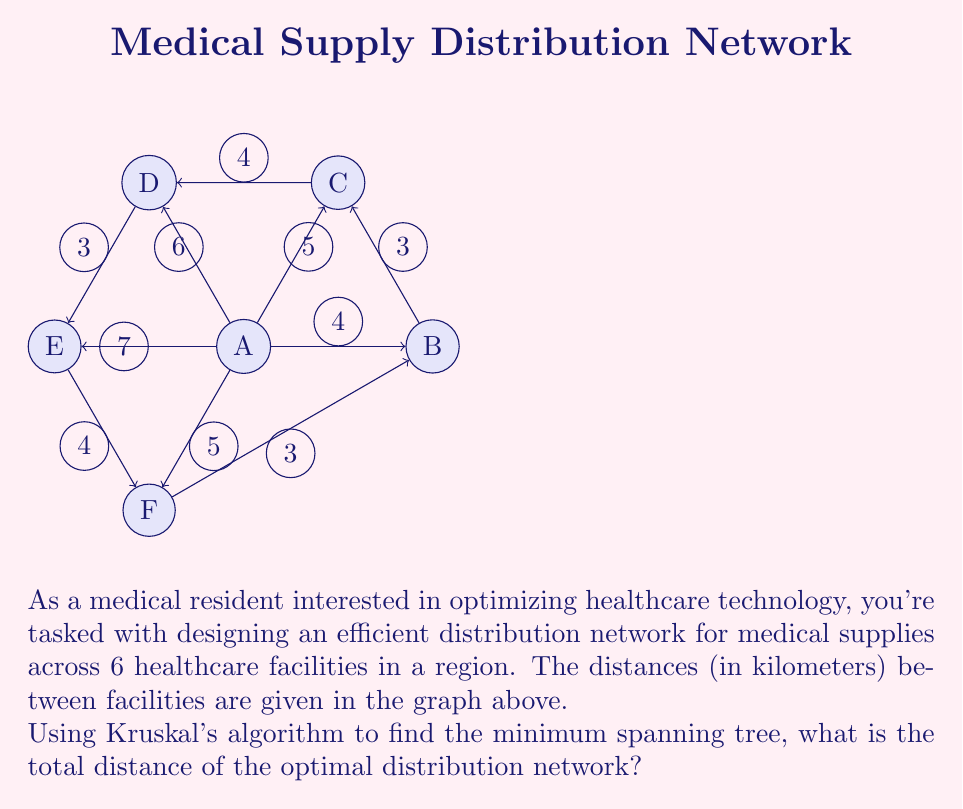Can you answer this question? Let's apply Kruskal's algorithm step-by-step to find the minimum spanning tree:

1) First, sort all edges by weight (distance) in ascending order:
   AB (4), BC (3), CD (4), DE (3), EF (4), FA (3), AC (5), AF (5), AD (6), AE (7)

2) Start with an empty set of edges and add edges in order, skipping those that would create a cycle:

   - Add FA (3)
   - Add BC (3)
   - Add DE (3)
   - Add AB (4)
   - Add CD (4)

3) At this point, we have added 5 edges, which is correct for a minimum spanning tree of 6 vertices (n-1 edges where n is the number of vertices).

4) The minimum spanning tree consists of the edges:
   FA (3), BC (3), DE (3), AB (4), CD (4)

5) To calculate the total distance, sum the weights of these edges:
   $$3 + 3 + 3 + 4 + 4 = 17$$

Therefore, the total distance of the optimal distribution network is 17 kilometers.
Answer: 17 km 